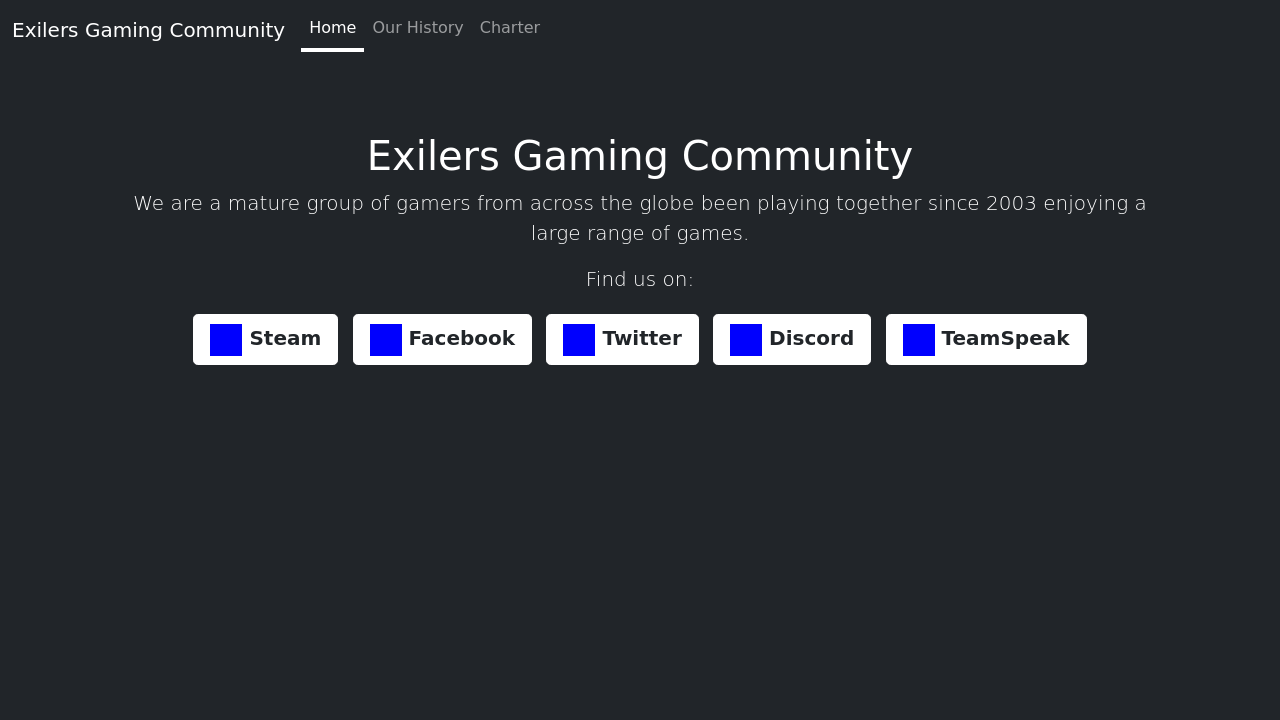Can you list and describe the types of games the Exilers Gaming Community is involved with? Absolutely! The Exilers Gaming Community is engaged in a wide variety of games spanning across multiple genres. These include strategy games, role-playing games (RPGs), first-person shooters (FPS), and multiplayer online battle arena (MOBA) games. Each genre offers a unique gaming experience catering to different player skills and preferences. Some popular examples might include 'Counter-Strike' for FPS, 'League of Legends' for MOBA, and 'World of Warcraft' for RPG. This diverse gaming portfolio helps in accommodating the distinct tastes of its global members. 